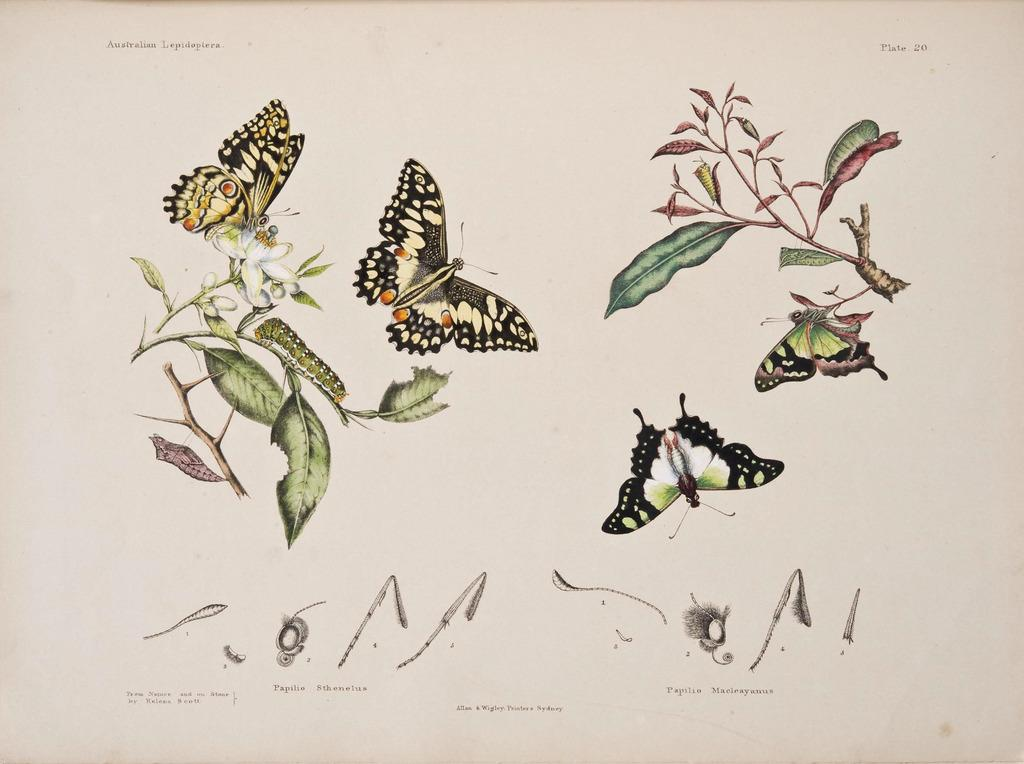What types of images can be seen in the picture? There are pictures of butterflies and plant leaves in the image. Can you describe the subjects of the images? The images feature butterflies and plant leaves. Where is the hill located in the image? There is no hill present in the image. What type of locket can be seen hanging from the butterfly's neck in the image? There are no lockets or butterflies with necks in the image; it only features pictures of butterflies and plant leaves. 